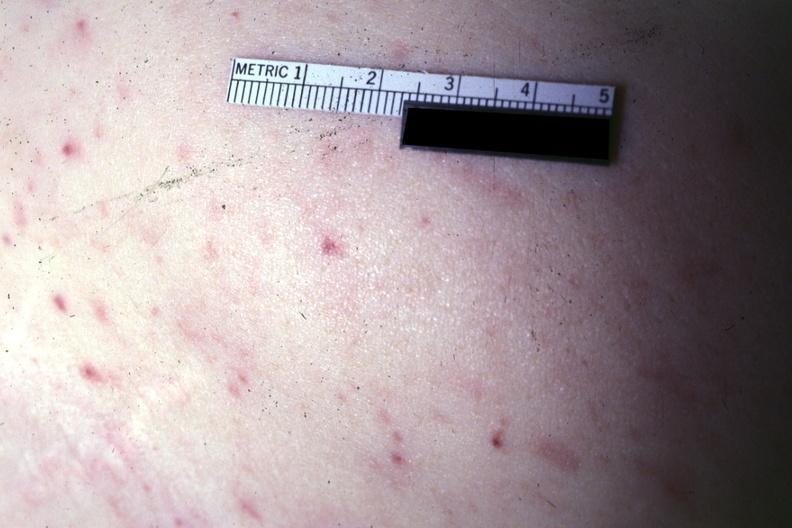what does this image show?
Answer the question using a single word or phrase. Lesions well shown 